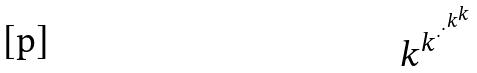Convert formula to latex. <formula><loc_0><loc_0><loc_500><loc_500>k ^ { k ^ { \cdot ^ { \cdot ^ { k ^ { k } } } } }</formula> 